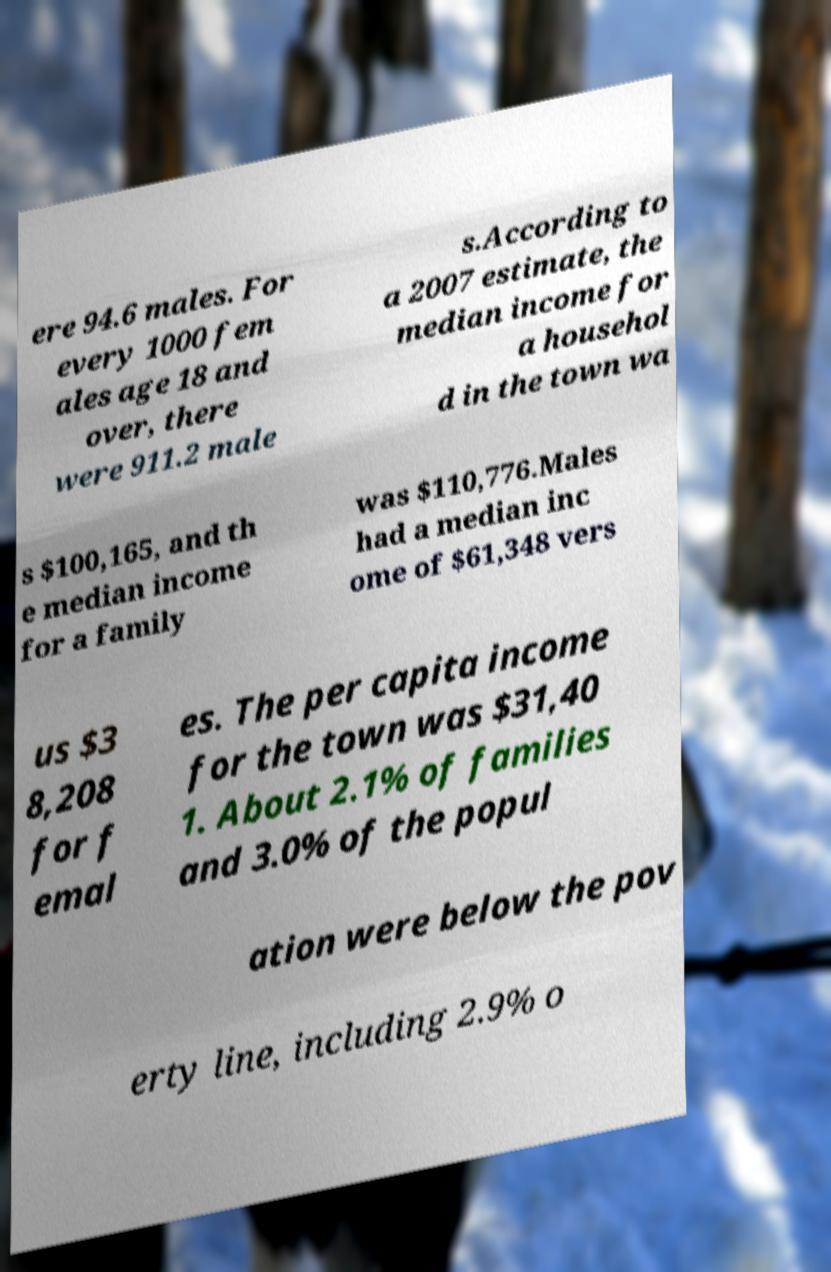Please identify and transcribe the text found in this image. ere 94.6 males. For every 1000 fem ales age 18 and over, there were 911.2 male s.According to a 2007 estimate, the median income for a househol d in the town wa s $100,165, and th e median income for a family was $110,776.Males had a median inc ome of $61,348 vers us $3 8,208 for f emal es. The per capita income for the town was $31,40 1. About 2.1% of families and 3.0% of the popul ation were below the pov erty line, including 2.9% o 